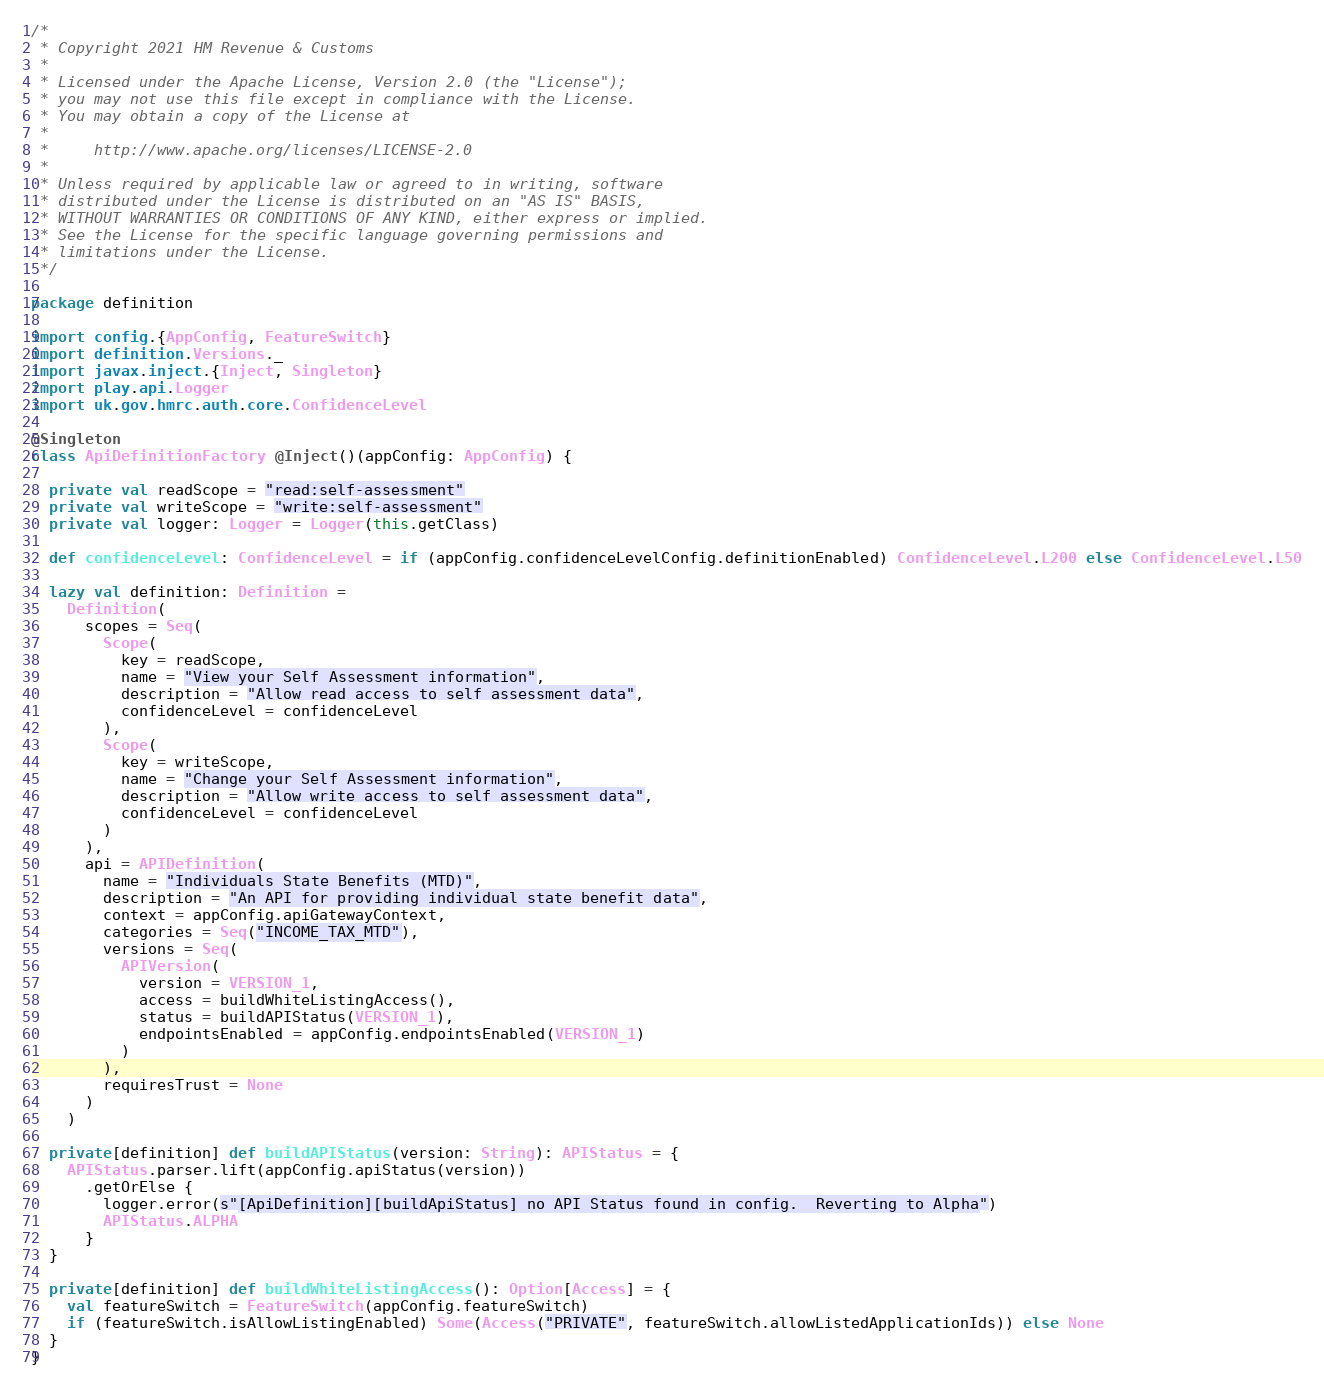<code> <loc_0><loc_0><loc_500><loc_500><_Scala_>/*
 * Copyright 2021 HM Revenue & Customs
 *
 * Licensed under the Apache License, Version 2.0 (the "License");
 * you may not use this file except in compliance with the License.
 * You may obtain a copy of the License at
 *
 *     http://www.apache.org/licenses/LICENSE-2.0
 *
 * Unless required by applicable law or agreed to in writing, software
 * distributed under the License is distributed on an "AS IS" BASIS,
 * WITHOUT WARRANTIES OR CONDITIONS OF ANY KIND, either express or implied.
 * See the License for the specific language governing permissions and
 * limitations under the License.
 */

package definition

import config.{AppConfig, FeatureSwitch}
import definition.Versions._
import javax.inject.{Inject, Singleton}
import play.api.Logger
import uk.gov.hmrc.auth.core.ConfidenceLevel

@Singleton
class ApiDefinitionFactory @Inject()(appConfig: AppConfig) {

  private val readScope = "read:self-assessment"
  private val writeScope = "write:self-assessment"
  private val logger: Logger = Logger(this.getClass)

  def confidenceLevel: ConfidenceLevel = if (appConfig.confidenceLevelConfig.definitionEnabled) ConfidenceLevel.L200 else ConfidenceLevel.L50

  lazy val definition: Definition =
    Definition(
      scopes = Seq(
        Scope(
          key = readScope,
          name = "View your Self Assessment information",
          description = "Allow read access to self assessment data",
          confidenceLevel = confidenceLevel
        ),
        Scope(
          key = writeScope,
          name = "Change your Self Assessment information",
          description = "Allow write access to self assessment data",
          confidenceLevel = confidenceLevel
        )
      ),
      api = APIDefinition(
        name = "Individuals State Benefits (MTD)",
        description = "An API for providing individual state benefit data",
        context = appConfig.apiGatewayContext,
        categories = Seq("INCOME_TAX_MTD"),
        versions = Seq(
          APIVersion(
            version = VERSION_1,
            access = buildWhiteListingAccess(),
            status = buildAPIStatus(VERSION_1),
            endpointsEnabled = appConfig.endpointsEnabled(VERSION_1)
          )
        ),
        requiresTrust = None
      )
    )

  private[definition] def buildAPIStatus(version: String): APIStatus = {
    APIStatus.parser.lift(appConfig.apiStatus(version))
      .getOrElse {
        logger.error(s"[ApiDefinition][buildApiStatus] no API Status found in config.  Reverting to Alpha")
        APIStatus.ALPHA
      }
  }

  private[definition] def buildWhiteListingAccess(): Option[Access] = {
    val featureSwitch = FeatureSwitch(appConfig.featureSwitch)
    if (featureSwitch.isAllowListingEnabled) Some(Access("PRIVATE", featureSwitch.allowListedApplicationIds)) else None
  }
}
</code> 